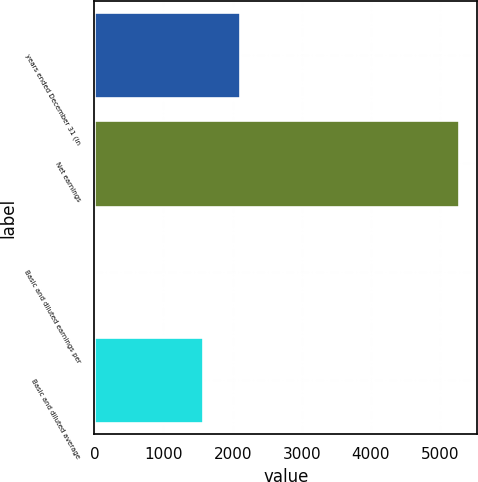<chart> <loc_0><loc_0><loc_500><loc_500><bar_chart><fcel>years ended December 31 (in<fcel>Net earnings<fcel>Basic and diluted earnings per<fcel>Basic and diluted average<nl><fcel>2104.16<fcel>5275<fcel>3.35<fcel>1577<nl></chart> 